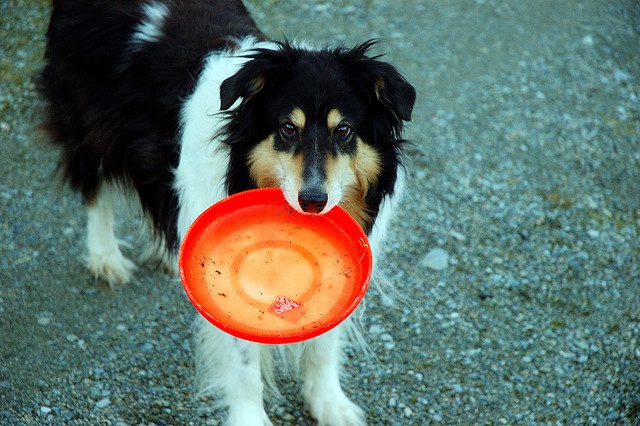Describe the objects in this image and their specific colors. I can see dog in teal, black, lightblue, orange, and red tones and frisbee in teal, orange, red, and tan tones in this image. 